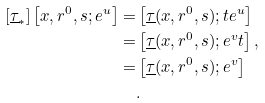Convert formula to latex. <formula><loc_0><loc_0><loc_500><loc_500>[ \underline { \tau } _ { * } ] \left [ x , { r ^ { 0 } } , s ; e ^ { u } \right ] = & \left [ \underline { \tau } ( x , { r ^ { 0 } } , s ) ; t e ^ { u } \right ] \\ = & \left [ \underline { \tau } ( x , { r ^ { 0 } } , s ) ; e ^ { v } t \right ] , \\ = & \left [ \underline { \tau } ( x , r ^ { 0 } , s ) ; e ^ { v } \right ] \\ & .</formula> 